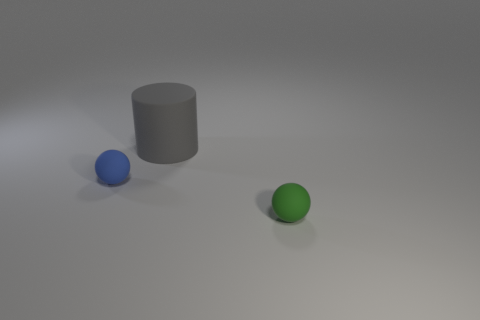Add 1 tiny blue rubber balls. How many objects exist? 4 Subtract all matte objects. Subtract all blue matte blocks. How many objects are left? 0 Add 1 matte objects. How many matte objects are left? 4 Add 1 big gray matte cylinders. How many big gray matte cylinders exist? 2 Subtract 1 gray cylinders. How many objects are left? 2 Subtract all balls. How many objects are left? 1 